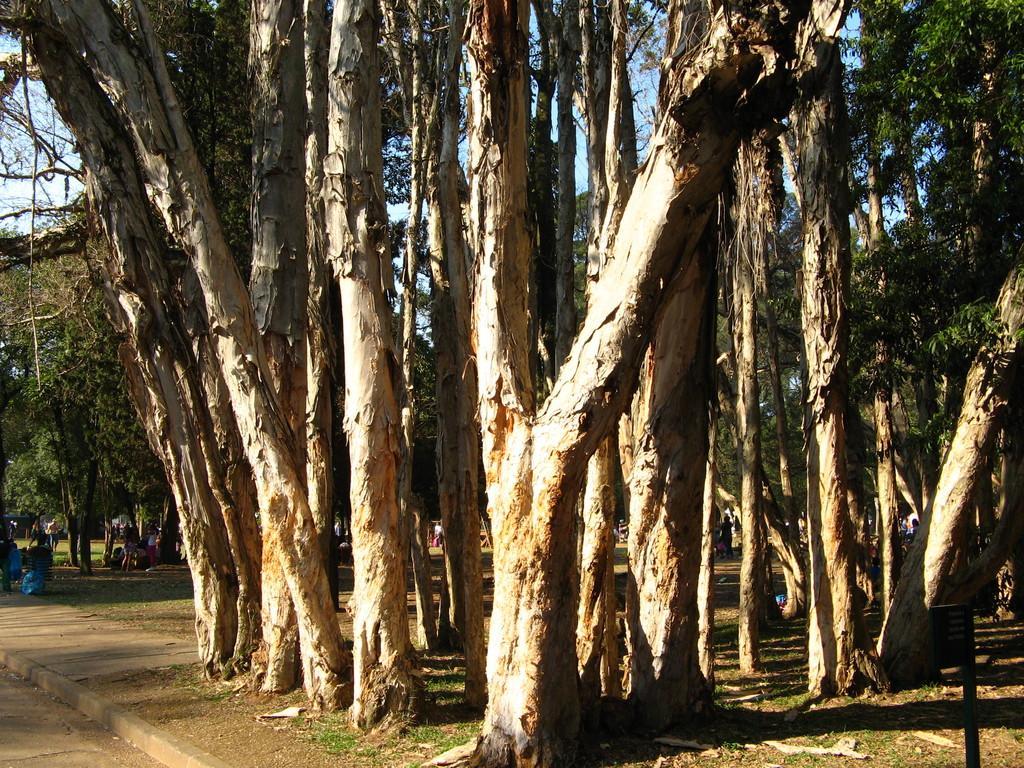How would you summarize this image in a sentence or two? In this image we can see the persons standing on the ground and there are few objects. We can see there are tree trunks, trees and the sky. 